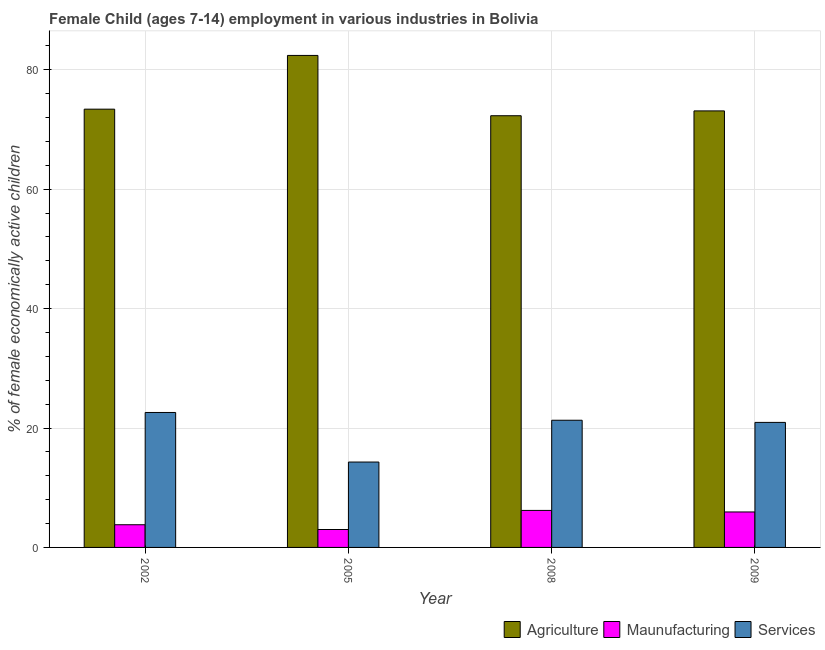Are the number of bars per tick equal to the number of legend labels?
Make the answer very short. Yes. Are the number of bars on each tick of the X-axis equal?
Provide a succinct answer. Yes. How many bars are there on the 2nd tick from the left?
Keep it short and to the point. 3. In how many cases, is the number of bars for a given year not equal to the number of legend labels?
Make the answer very short. 0. What is the percentage of economically active children in services in 2002?
Your answer should be very brief. 22.6. Across all years, what is the maximum percentage of economically active children in agriculture?
Provide a succinct answer. 82.4. Across all years, what is the minimum percentage of economically active children in services?
Offer a very short reply. 14.3. In which year was the percentage of economically active children in agriculture maximum?
Offer a terse response. 2005. What is the total percentage of economically active children in manufacturing in the graph?
Give a very brief answer. 18.94. What is the difference between the percentage of economically active children in services in 2002 and that in 2005?
Give a very brief answer. 8.3. What is the difference between the percentage of economically active children in agriculture in 2009 and the percentage of economically active children in manufacturing in 2005?
Your answer should be compact. -9.29. What is the average percentage of economically active children in manufacturing per year?
Your response must be concise. 4.74. What is the ratio of the percentage of economically active children in services in 2008 to that in 2009?
Ensure brevity in your answer.  1.02. Is the difference between the percentage of economically active children in services in 2002 and 2009 greater than the difference between the percentage of economically active children in agriculture in 2002 and 2009?
Keep it short and to the point. No. What is the difference between the highest and the lowest percentage of economically active children in agriculture?
Offer a very short reply. 10.1. Is the sum of the percentage of economically active children in agriculture in 2005 and 2009 greater than the maximum percentage of economically active children in manufacturing across all years?
Offer a very short reply. Yes. What does the 2nd bar from the left in 2002 represents?
Give a very brief answer. Maunufacturing. What does the 1st bar from the right in 2002 represents?
Offer a terse response. Services. How many bars are there?
Your answer should be very brief. 12. Are all the bars in the graph horizontal?
Give a very brief answer. No. Does the graph contain any zero values?
Offer a very short reply. No. Where does the legend appear in the graph?
Your answer should be very brief. Bottom right. How many legend labels are there?
Ensure brevity in your answer.  3. How are the legend labels stacked?
Ensure brevity in your answer.  Horizontal. What is the title of the graph?
Your answer should be compact. Female Child (ages 7-14) employment in various industries in Bolivia. Does "Agriculture" appear as one of the legend labels in the graph?
Ensure brevity in your answer.  Yes. What is the label or title of the X-axis?
Your answer should be very brief. Year. What is the label or title of the Y-axis?
Provide a succinct answer. % of female economically active children. What is the % of female economically active children of Agriculture in 2002?
Give a very brief answer. 73.4. What is the % of female economically active children in Services in 2002?
Offer a very short reply. 22.6. What is the % of female economically active children in Agriculture in 2005?
Offer a very short reply. 82.4. What is the % of female economically active children of Maunufacturing in 2005?
Your answer should be very brief. 3. What is the % of female economically active children in Services in 2005?
Offer a very short reply. 14.3. What is the % of female economically active children in Agriculture in 2008?
Your response must be concise. 72.3. What is the % of female economically active children of Maunufacturing in 2008?
Provide a short and direct response. 6.2. What is the % of female economically active children of Services in 2008?
Provide a succinct answer. 21.3. What is the % of female economically active children of Agriculture in 2009?
Give a very brief answer. 73.11. What is the % of female economically active children of Maunufacturing in 2009?
Provide a short and direct response. 5.94. What is the % of female economically active children of Services in 2009?
Your response must be concise. 20.94. Across all years, what is the maximum % of female economically active children of Agriculture?
Offer a very short reply. 82.4. Across all years, what is the maximum % of female economically active children of Services?
Your answer should be compact. 22.6. Across all years, what is the minimum % of female economically active children in Agriculture?
Ensure brevity in your answer.  72.3. Across all years, what is the minimum % of female economically active children of Maunufacturing?
Your response must be concise. 3. What is the total % of female economically active children in Agriculture in the graph?
Provide a succinct answer. 301.21. What is the total % of female economically active children of Maunufacturing in the graph?
Provide a short and direct response. 18.94. What is the total % of female economically active children in Services in the graph?
Offer a very short reply. 79.14. What is the difference between the % of female economically active children of Maunufacturing in 2002 and that in 2005?
Give a very brief answer. 0.8. What is the difference between the % of female economically active children in Services in 2002 and that in 2008?
Offer a very short reply. 1.3. What is the difference between the % of female economically active children of Agriculture in 2002 and that in 2009?
Keep it short and to the point. 0.29. What is the difference between the % of female economically active children of Maunufacturing in 2002 and that in 2009?
Offer a very short reply. -2.14. What is the difference between the % of female economically active children in Services in 2002 and that in 2009?
Offer a terse response. 1.66. What is the difference between the % of female economically active children of Agriculture in 2005 and that in 2009?
Keep it short and to the point. 9.29. What is the difference between the % of female economically active children in Maunufacturing in 2005 and that in 2009?
Make the answer very short. -2.94. What is the difference between the % of female economically active children in Services in 2005 and that in 2009?
Make the answer very short. -6.64. What is the difference between the % of female economically active children of Agriculture in 2008 and that in 2009?
Provide a succinct answer. -0.81. What is the difference between the % of female economically active children of Maunufacturing in 2008 and that in 2009?
Offer a terse response. 0.26. What is the difference between the % of female economically active children of Services in 2008 and that in 2009?
Ensure brevity in your answer.  0.36. What is the difference between the % of female economically active children in Agriculture in 2002 and the % of female economically active children in Maunufacturing in 2005?
Make the answer very short. 70.4. What is the difference between the % of female economically active children in Agriculture in 2002 and the % of female economically active children in Services in 2005?
Your response must be concise. 59.1. What is the difference between the % of female economically active children in Agriculture in 2002 and the % of female economically active children in Maunufacturing in 2008?
Make the answer very short. 67.2. What is the difference between the % of female economically active children of Agriculture in 2002 and the % of female economically active children of Services in 2008?
Your answer should be compact. 52.1. What is the difference between the % of female economically active children in Maunufacturing in 2002 and the % of female economically active children in Services in 2008?
Provide a succinct answer. -17.5. What is the difference between the % of female economically active children of Agriculture in 2002 and the % of female economically active children of Maunufacturing in 2009?
Offer a very short reply. 67.46. What is the difference between the % of female economically active children of Agriculture in 2002 and the % of female economically active children of Services in 2009?
Offer a very short reply. 52.46. What is the difference between the % of female economically active children in Maunufacturing in 2002 and the % of female economically active children in Services in 2009?
Your answer should be compact. -17.14. What is the difference between the % of female economically active children in Agriculture in 2005 and the % of female economically active children in Maunufacturing in 2008?
Keep it short and to the point. 76.2. What is the difference between the % of female economically active children in Agriculture in 2005 and the % of female economically active children in Services in 2008?
Give a very brief answer. 61.1. What is the difference between the % of female economically active children in Maunufacturing in 2005 and the % of female economically active children in Services in 2008?
Offer a very short reply. -18.3. What is the difference between the % of female economically active children of Agriculture in 2005 and the % of female economically active children of Maunufacturing in 2009?
Your answer should be very brief. 76.46. What is the difference between the % of female economically active children of Agriculture in 2005 and the % of female economically active children of Services in 2009?
Provide a succinct answer. 61.46. What is the difference between the % of female economically active children of Maunufacturing in 2005 and the % of female economically active children of Services in 2009?
Offer a terse response. -17.94. What is the difference between the % of female economically active children in Agriculture in 2008 and the % of female economically active children in Maunufacturing in 2009?
Offer a terse response. 66.36. What is the difference between the % of female economically active children of Agriculture in 2008 and the % of female economically active children of Services in 2009?
Your answer should be very brief. 51.36. What is the difference between the % of female economically active children of Maunufacturing in 2008 and the % of female economically active children of Services in 2009?
Keep it short and to the point. -14.74. What is the average % of female economically active children in Agriculture per year?
Provide a succinct answer. 75.3. What is the average % of female economically active children of Maunufacturing per year?
Provide a succinct answer. 4.74. What is the average % of female economically active children of Services per year?
Your answer should be very brief. 19.79. In the year 2002, what is the difference between the % of female economically active children of Agriculture and % of female economically active children of Maunufacturing?
Your answer should be compact. 69.6. In the year 2002, what is the difference between the % of female economically active children of Agriculture and % of female economically active children of Services?
Your answer should be compact. 50.8. In the year 2002, what is the difference between the % of female economically active children in Maunufacturing and % of female economically active children in Services?
Your response must be concise. -18.8. In the year 2005, what is the difference between the % of female economically active children in Agriculture and % of female economically active children in Maunufacturing?
Your response must be concise. 79.4. In the year 2005, what is the difference between the % of female economically active children of Agriculture and % of female economically active children of Services?
Ensure brevity in your answer.  68.1. In the year 2005, what is the difference between the % of female economically active children in Maunufacturing and % of female economically active children in Services?
Provide a short and direct response. -11.3. In the year 2008, what is the difference between the % of female economically active children of Agriculture and % of female economically active children of Maunufacturing?
Offer a very short reply. 66.1. In the year 2008, what is the difference between the % of female economically active children of Maunufacturing and % of female economically active children of Services?
Ensure brevity in your answer.  -15.1. In the year 2009, what is the difference between the % of female economically active children in Agriculture and % of female economically active children in Maunufacturing?
Make the answer very short. 67.17. In the year 2009, what is the difference between the % of female economically active children in Agriculture and % of female economically active children in Services?
Provide a short and direct response. 52.17. What is the ratio of the % of female economically active children of Agriculture in 2002 to that in 2005?
Ensure brevity in your answer.  0.89. What is the ratio of the % of female economically active children of Maunufacturing in 2002 to that in 2005?
Ensure brevity in your answer.  1.27. What is the ratio of the % of female economically active children of Services in 2002 to that in 2005?
Offer a very short reply. 1.58. What is the ratio of the % of female economically active children in Agriculture in 2002 to that in 2008?
Keep it short and to the point. 1.02. What is the ratio of the % of female economically active children in Maunufacturing in 2002 to that in 2008?
Give a very brief answer. 0.61. What is the ratio of the % of female economically active children in Services in 2002 to that in 2008?
Your answer should be compact. 1.06. What is the ratio of the % of female economically active children in Agriculture in 2002 to that in 2009?
Offer a terse response. 1. What is the ratio of the % of female economically active children of Maunufacturing in 2002 to that in 2009?
Your answer should be compact. 0.64. What is the ratio of the % of female economically active children of Services in 2002 to that in 2009?
Your answer should be compact. 1.08. What is the ratio of the % of female economically active children of Agriculture in 2005 to that in 2008?
Your response must be concise. 1.14. What is the ratio of the % of female economically active children of Maunufacturing in 2005 to that in 2008?
Ensure brevity in your answer.  0.48. What is the ratio of the % of female economically active children of Services in 2005 to that in 2008?
Provide a succinct answer. 0.67. What is the ratio of the % of female economically active children of Agriculture in 2005 to that in 2009?
Provide a succinct answer. 1.13. What is the ratio of the % of female economically active children in Maunufacturing in 2005 to that in 2009?
Provide a short and direct response. 0.51. What is the ratio of the % of female economically active children in Services in 2005 to that in 2009?
Your answer should be compact. 0.68. What is the ratio of the % of female economically active children in Agriculture in 2008 to that in 2009?
Ensure brevity in your answer.  0.99. What is the ratio of the % of female economically active children in Maunufacturing in 2008 to that in 2009?
Provide a short and direct response. 1.04. What is the ratio of the % of female economically active children in Services in 2008 to that in 2009?
Make the answer very short. 1.02. What is the difference between the highest and the second highest % of female economically active children of Maunufacturing?
Give a very brief answer. 0.26. What is the difference between the highest and the second highest % of female economically active children of Services?
Make the answer very short. 1.3. 